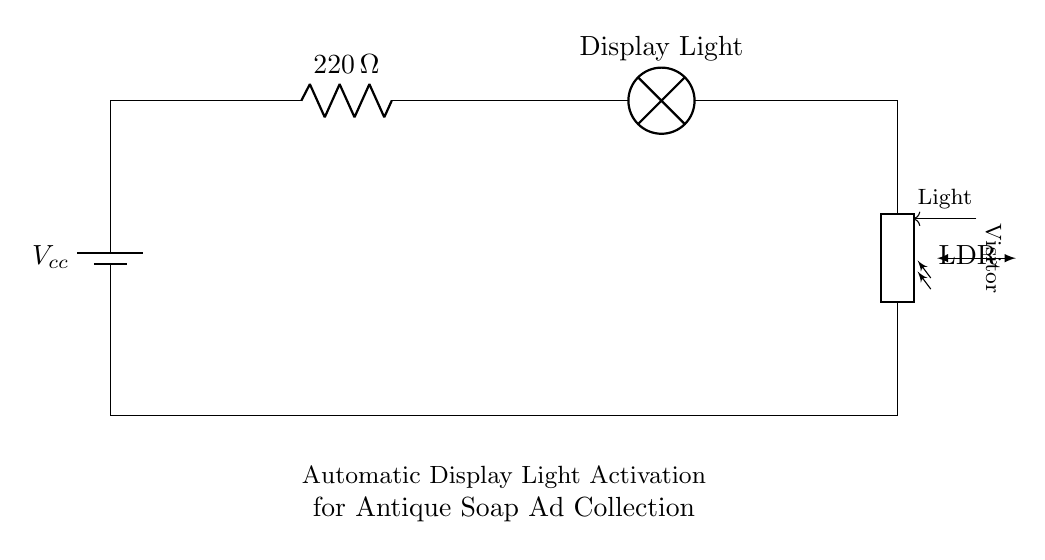What is the resistance value in this circuit? The resistance value shown in the circuit is 220 ohms, as indicated next to the resistor symbol in the diagram.
Answer: 220 ohms How many lamps are in the circuit? There is one lamp indicated in the circuit as the "Display Light" which is the component responsible for illuminating when activated.
Answer: One What role does the photoresistor play in the circuit? The photoresistor, or LDR, detects light levels and helps to automatically activate the display light when a visitor approaches, acting as a switch based on light conditions.
Answer: Automatic light activation What is the power source type in this circuit? The circuit uses a battery as indicated by the "Vcc" labeling next to the battery symbol, implying it supplies the necessary voltage.
Answer: Battery What happens when a visitor approaches the circuit? When a visitor approaches, the light conditions change which prompts the photoresistor to trigger the display light, illuminating the antique soap ad collection automatically.
Answer: Lights activate What is a key benefit of using a photoresistor in this circuit? The advantage of using a photoresistor is that it allows for automatic sensing and control of the display lights based on the presence of visitors, enhancing user interaction.
Answer: Automatic sensing 